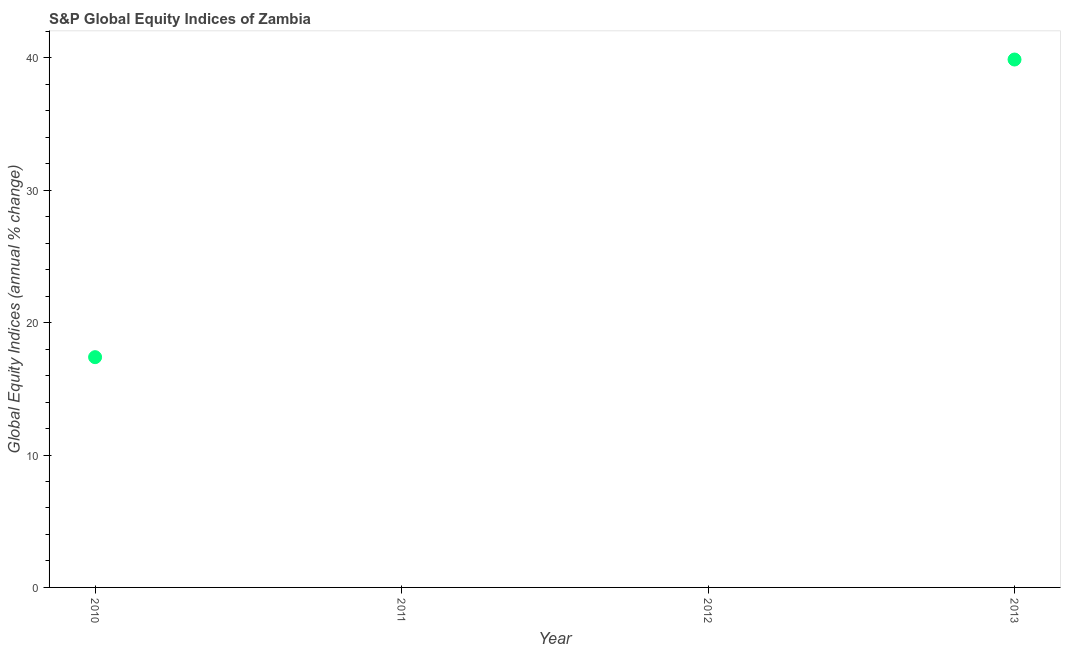What is the s&p global equity indices in 2013?
Your response must be concise. 39.87. Across all years, what is the maximum s&p global equity indices?
Keep it short and to the point. 39.87. Across all years, what is the minimum s&p global equity indices?
Give a very brief answer. 0. In which year was the s&p global equity indices maximum?
Your response must be concise. 2013. What is the sum of the s&p global equity indices?
Make the answer very short. 57.26. What is the difference between the s&p global equity indices in 2010 and 2013?
Offer a terse response. -22.48. What is the average s&p global equity indices per year?
Provide a short and direct response. 14.31. What is the median s&p global equity indices?
Your response must be concise. 8.69. What is the ratio of the s&p global equity indices in 2010 to that in 2013?
Provide a short and direct response. 0.44. What is the difference between the highest and the lowest s&p global equity indices?
Keep it short and to the point. 39.87. In how many years, is the s&p global equity indices greater than the average s&p global equity indices taken over all years?
Provide a succinct answer. 2. How many years are there in the graph?
Your answer should be very brief. 4. Does the graph contain any zero values?
Provide a short and direct response. Yes. Does the graph contain grids?
Your answer should be very brief. No. What is the title of the graph?
Make the answer very short. S&P Global Equity Indices of Zambia. What is the label or title of the Y-axis?
Your answer should be very brief. Global Equity Indices (annual % change). What is the Global Equity Indices (annual % change) in 2010?
Your response must be concise. 17.39. What is the Global Equity Indices (annual % change) in 2011?
Provide a succinct answer. 0. What is the Global Equity Indices (annual % change) in 2013?
Provide a succinct answer. 39.87. What is the difference between the Global Equity Indices (annual % change) in 2010 and 2013?
Keep it short and to the point. -22.48. What is the ratio of the Global Equity Indices (annual % change) in 2010 to that in 2013?
Offer a very short reply. 0.44. 